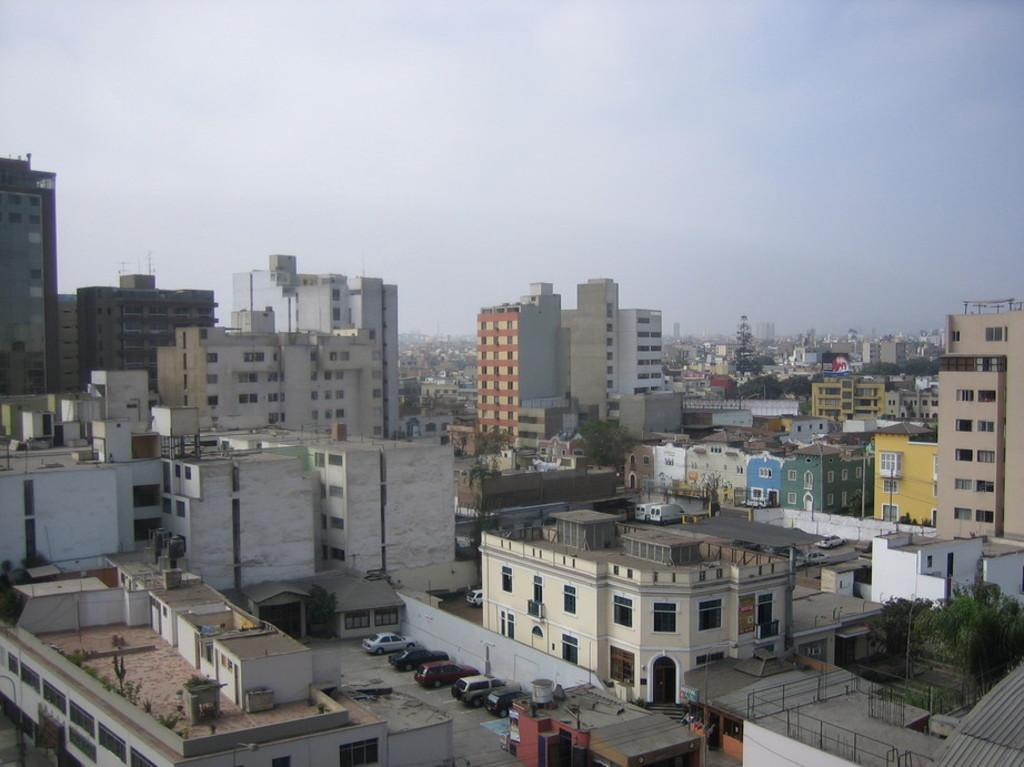What type of structures can be seen in the image? There are many buildings in the image. What type of vehicles are present in the image? There are cars in the image. What type of vegetation can be seen in the image? There are trees in the image. What type of vertical structures are present in the image? There are poles in the image. What is visible at the top of the image? The sky is visible at the top of the image. How many pizzas are on top of the buildings in the image? There are no pizzas present in the image; it features buildings, cars, trees, poles, and the sky. What type of roll is visible in the image? There is no roll present in the image. 